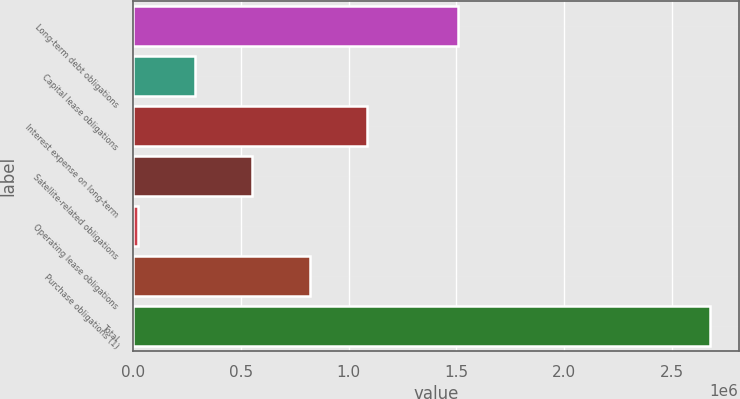Convert chart. <chart><loc_0><loc_0><loc_500><loc_500><bar_chart><fcel>Long-term debt obligations<fcel>Capital lease obligations<fcel>Interest expense on long-term<fcel>Satellite-related obligations<fcel>Operating lease obligations<fcel>Purchase obligations (1)<fcel>Total<nl><fcel>1.50674e+06<fcel>288270<fcel>1.08445e+06<fcel>553662<fcel>22878<fcel>819054<fcel>2.6768e+06<nl></chart> 